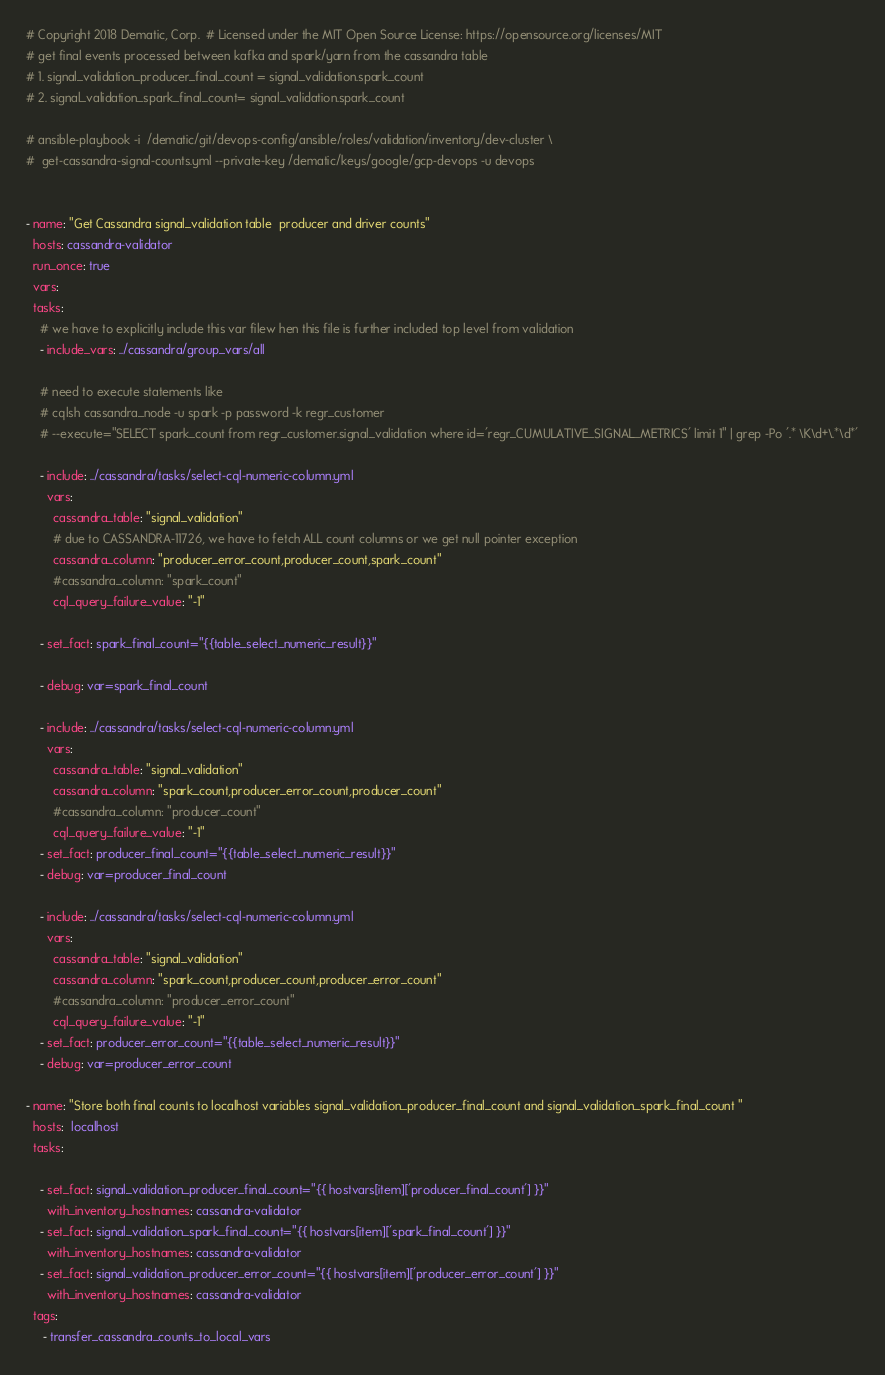Convert code to text. <code><loc_0><loc_0><loc_500><loc_500><_YAML_># Copyright 2018 Dematic, Corp.  # Licensed under the MIT Open Source License: https://opensource.org/licenses/MIT
# get final events processed between kafka and spark/yarn from the cassandra table
# 1. signal_validation_producer_final_count = signal_validation.spark_count
# 2. signal_validation_spark_final_count= signal_validation.spark_count

# ansible-playbook -i  /dematic/git/devops-config/ansible/roles/validation/inventory/dev-cluster \
#  get-cassandra-signal-counts.yml --private-key /dematic/keys/google/gcp-devops -u devops


- name: "Get Cassandra signal_validation table  producer and driver counts"
  hosts: cassandra-validator
  run_once: true
  vars:
  tasks:
    # we have to explicitly include this var filew hen this file is further included top level from validation
    - include_vars: ../cassandra/group_vars/all

    # need to execute statements like
    # cqlsh cassandra_node -u spark -p password -k regr_customer
    # --execute="SELECT spark_count from regr_customer.signal_validation where id='regr_CUMULATIVE_SIGNAL_METRICS' limit 1" | grep -Po '.* \K\d+\.*\d*'

    - include: ../cassandra/tasks/select-cql-numeric-column.yml
      vars:
        cassandra_table: "signal_validation"
        # due to CASSANDRA-11726, we have to fetch ALL count columns or we get null pointer exception
        cassandra_column: "producer_error_count,producer_count,spark_count"
        #cassandra_column: "spark_count"
        cql_query_failure_value: "-1"

    - set_fact: spark_final_count="{{table_select_numeric_result}}"

    - debug: var=spark_final_count

    - include: ../cassandra/tasks/select-cql-numeric-column.yml
      vars:
        cassandra_table: "signal_validation"
        cassandra_column: "spark_count,producer_error_count,producer_count"
        #cassandra_column: "producer_count"
        cql_query_failure_value: "-1"
    - set_fact: producer_final_count="{{table_select_numeric_result}}"
    - debug: var=producer_final_count

    - include: ../cassandra/tasks/select-cql-numeric-column.yml
      vars:
        cassandra_table: "signal_validation"
        cassandra_column: "spark_count,producer_count,producer_error_count"
        #cassandra_column: "producer_error_count"
        cql_query_failure_value: "-1"
    - set_fact: producer_error_count="{{table_select_numeric_result}}"
    - debug: var=producer_error_count

- name: "Store both final counts to localhost variables signal_validation_producer_final_count and signal_validation_spark_final_count "
  hosts:  localhost
  tasks:

    - set_fact: signal_validation_producer_final_count="{{ hostvars[item]['producer_final_count'] }}"
      with_inventory_hostnames: cassandra-validator
    - set_fact: signal_validation_spark_final_count="{{ hostvars[item]['spark_final_count'] }}"
      with_inventory_hostnames: cassandra-validator
    - set_fact: signal_validation_producer_error_count="{{ hostvars[item]['producer_error_count'] }}"
      with_inventory_hostnames: cassandra-validator
  tags:
     - transfer_cassandra_counts_to_local_vars
</code> 